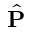Convert formula to latex. <formula><loc_0><loc_0><loc_500><loc_500>\hat { P }</formula> 